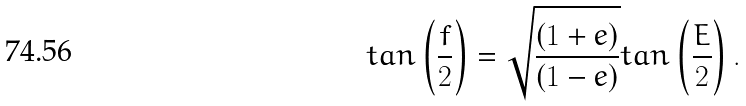<formula> <loc_0><loc_0><loc_500><loc_500>t a n \left ( \frac { f } { 2 } \right ) = \sqrt { \frac { ( 1 + e ) } { ( 1 - e ) } } t a n \left ( \frac { E } { 2 } \right ) .</formula> 